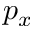Convert formula to latex. <formula><loc_0><loc_0><loc_500><loc_500>p _ { x }</formula> 